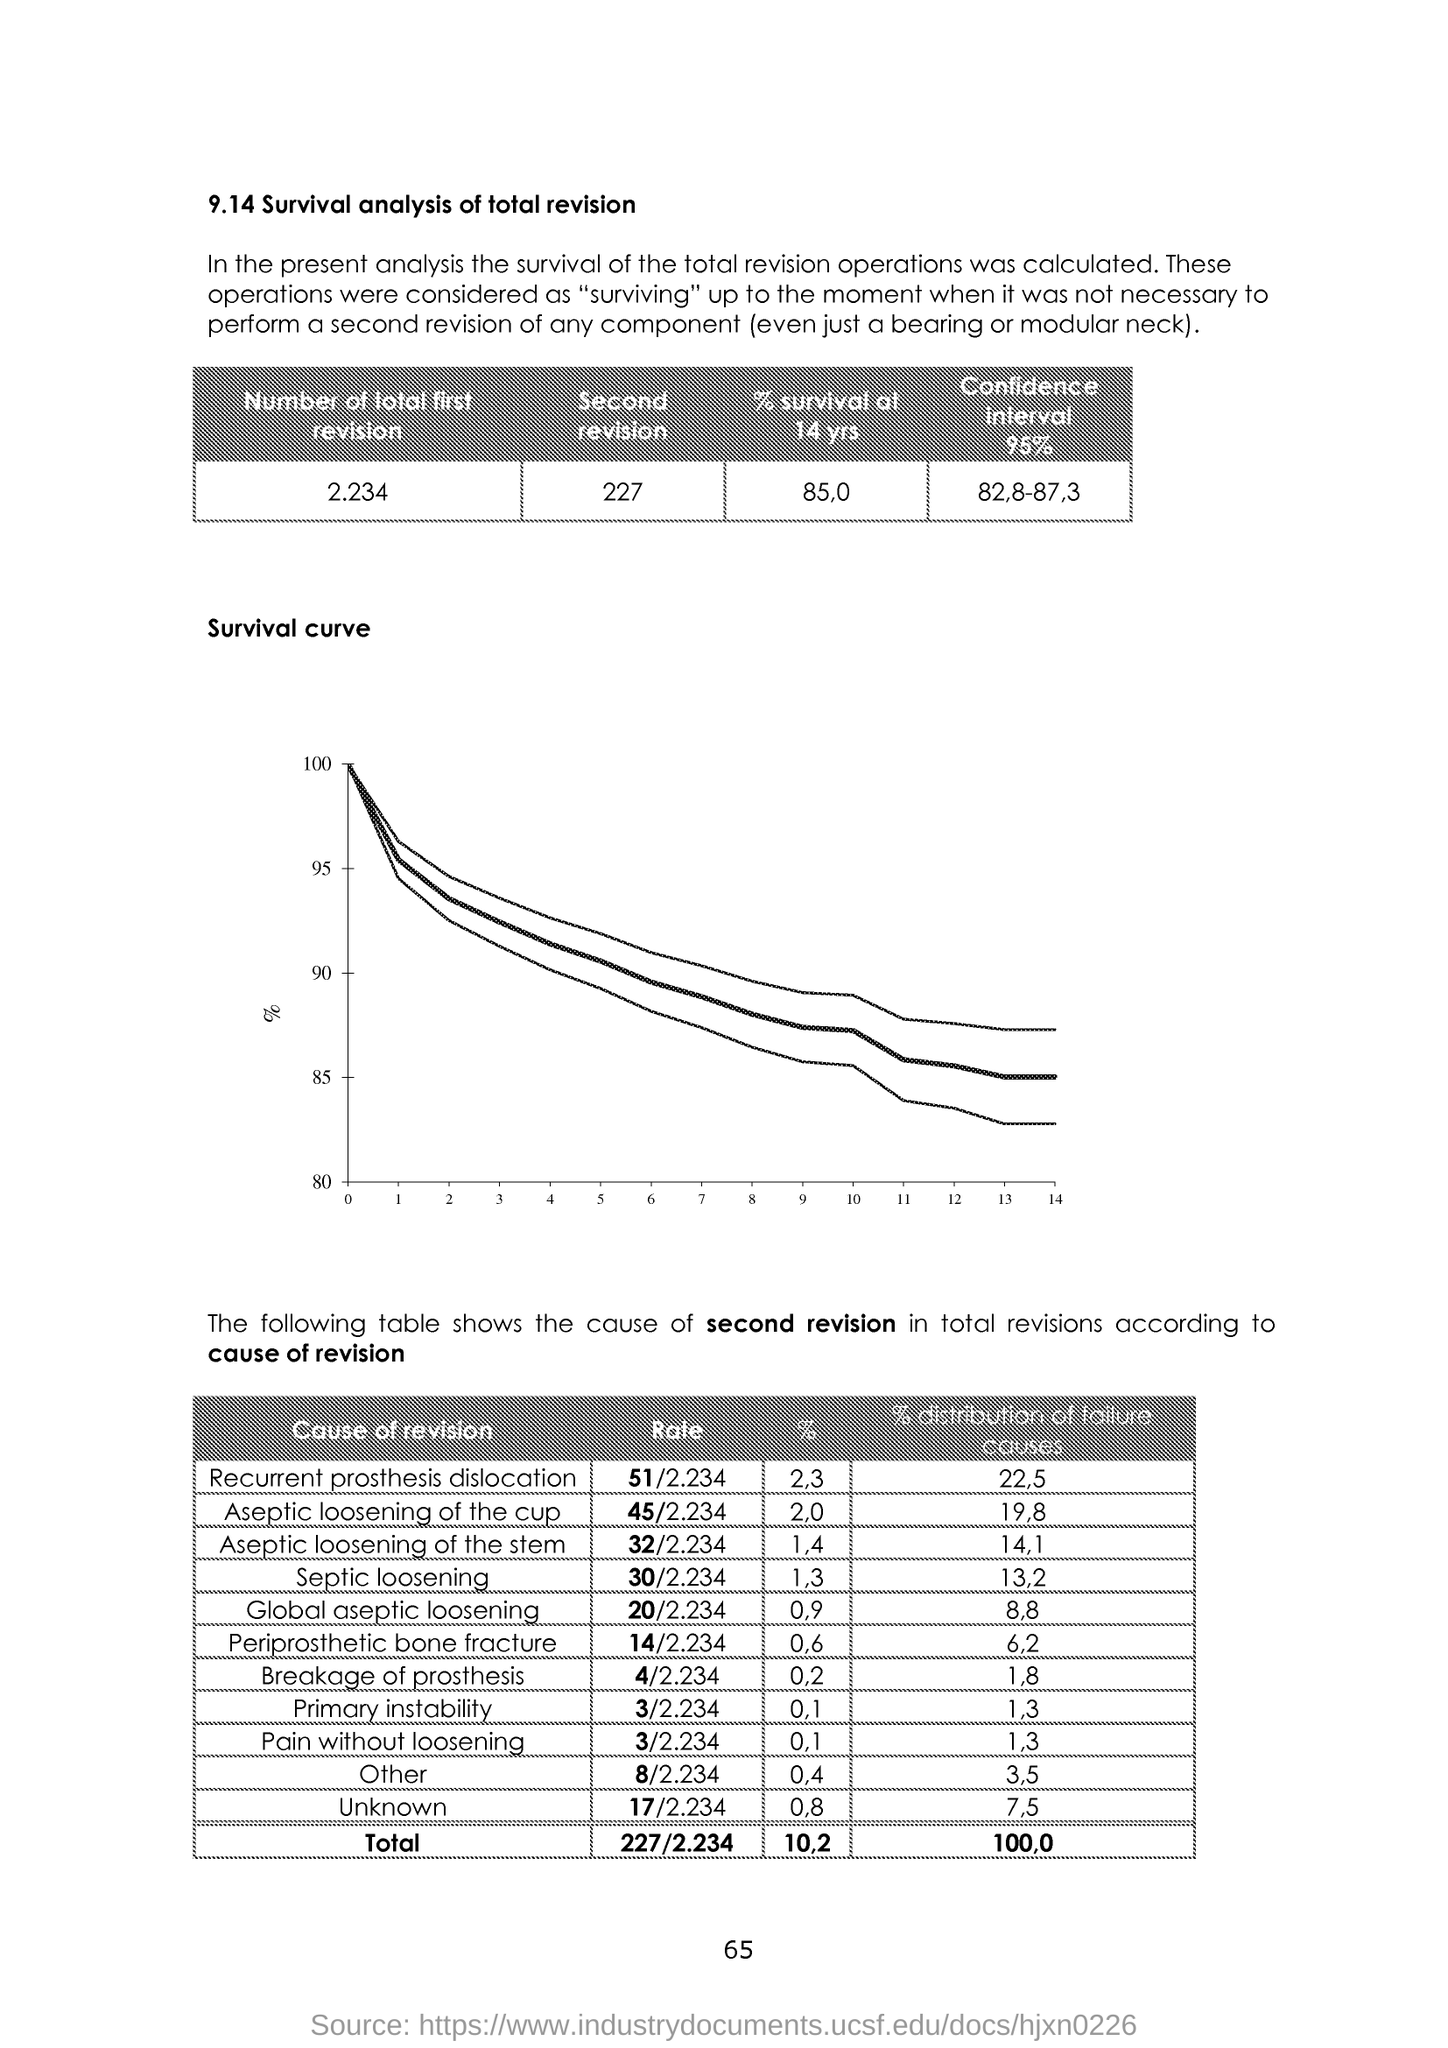Identify some key points in this picture. The total number of seconds for the second revision is 227. The total number of revisions for the first draft is 2.234... We conducted a study to determine the percentage of recurrent prosthesis dislocation, and the result was 2.3%. The rate of aseptic loosening of the cup is 2.0%. Septic loosening occurs in approximately 1-3% of patients undergoing elective hip or knee arthroplasty. 